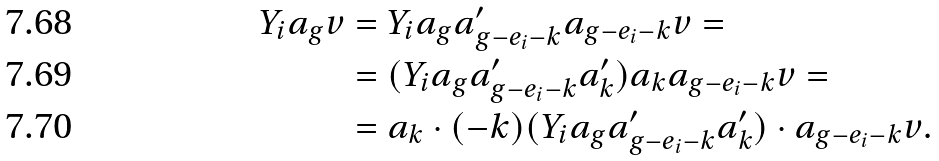Convert formula to latex. <formula><loc_0><loc_0><loc_500><loc_500>Y _ { i } a _ { g } v & = Y _ { i } a _ { g } a _ { g - e _ { i } - k } ^ { \prime } a _ { g - e _ { i } - k } v = \\ & = ( Y _ { i } a _ { g } a _ { g - e _ { i } - k } ^ { \prime } a _ { k } ^ { \prime } ) a _ { k } a _ { g - e _ { i } - k } v = \\ & = a _ { k } \cdot ( - k ) ( Y _ { i } a _ { g } a _ { g - e _ { i } - k } ^ { \prime } a _ { k } ^ { \prime } ) \cdot a _ { g - e _ { i } - k } v .</formula> 